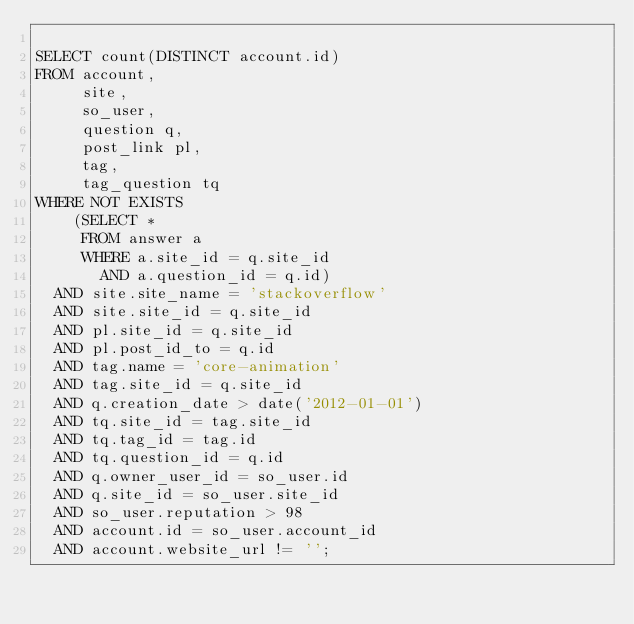Convert code to text. <code><loc_0><loc_0><loc_500><loc_500><_SQL_>
SELECT count(DISTINCT account.id)
FROM account,
     site,
     so_user,
     question q,
     post_link pl,
     tag,
     tag_question tq
WHERE NOT EXISTS
    (SELECT *
     FROM answer a
     WHERE a.site_id = q.site_id
       AND a.question_id = q.id)
  AND site.site_name = 'stackoverflow'
  AND site.site_id = q.site_id
  AND pl.site_id = q.site_id
  AND pl.post_id_to = q.id
  AND tag.name = 'core-animation'
  AND tag.site_id = q.site_id
  AND q.creation_date > date('2012-01-01')
  AND tq.site_id = tag.site_id
  AND tq.tag_id = tag.id
  AND tq.question_id = q.id
  AND q.owner_user_id = so_user.id
  AND q.site_id = so_user.site_id
  AND so_user.reputation > 98
  AND account.id = so_user.account_id
  AND account.website_url != '';</code> 